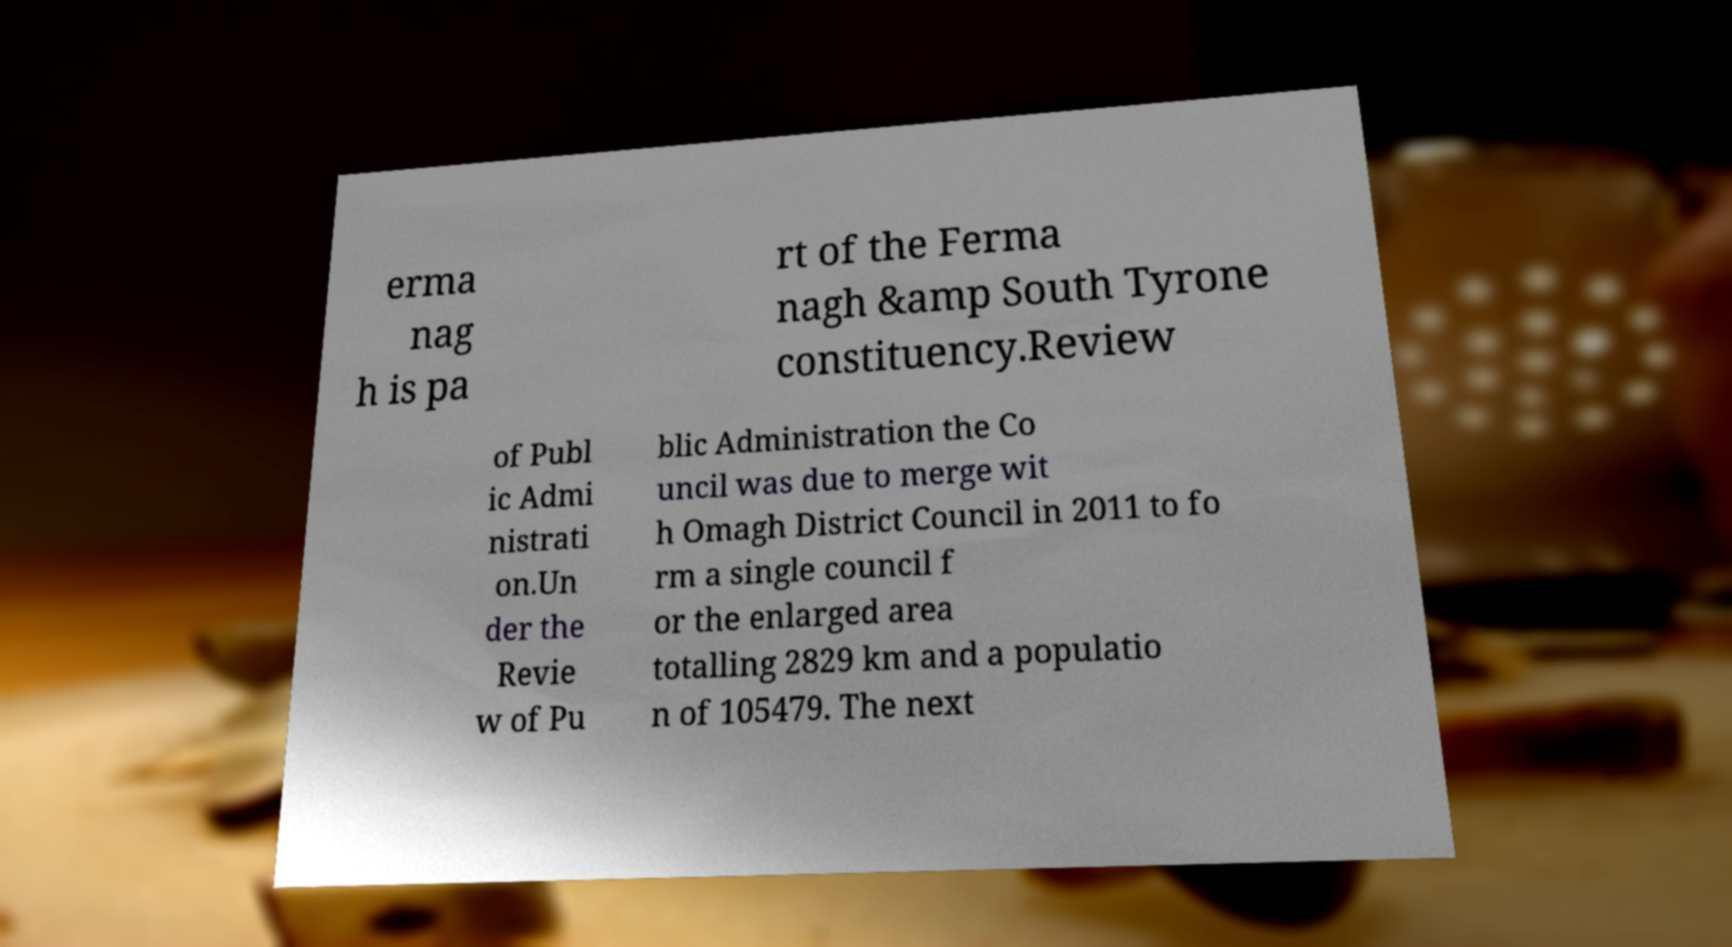Can you read and provide the text displayed in the image?This photo seems to have some interesting text. Can you extract and type it out for me? erma nag h is pa rt of the Ferma nagh &amp South Tyrone constituency.Review of Publ ic Admi nistrati on.Un der the Revie w of Pu blic Administration the Co uncil was due to merge wit h Omagh District Council in 2011 to fo rm a single council f or the enlarged area totalling 2829 km and a populatio n of 105479. The next 